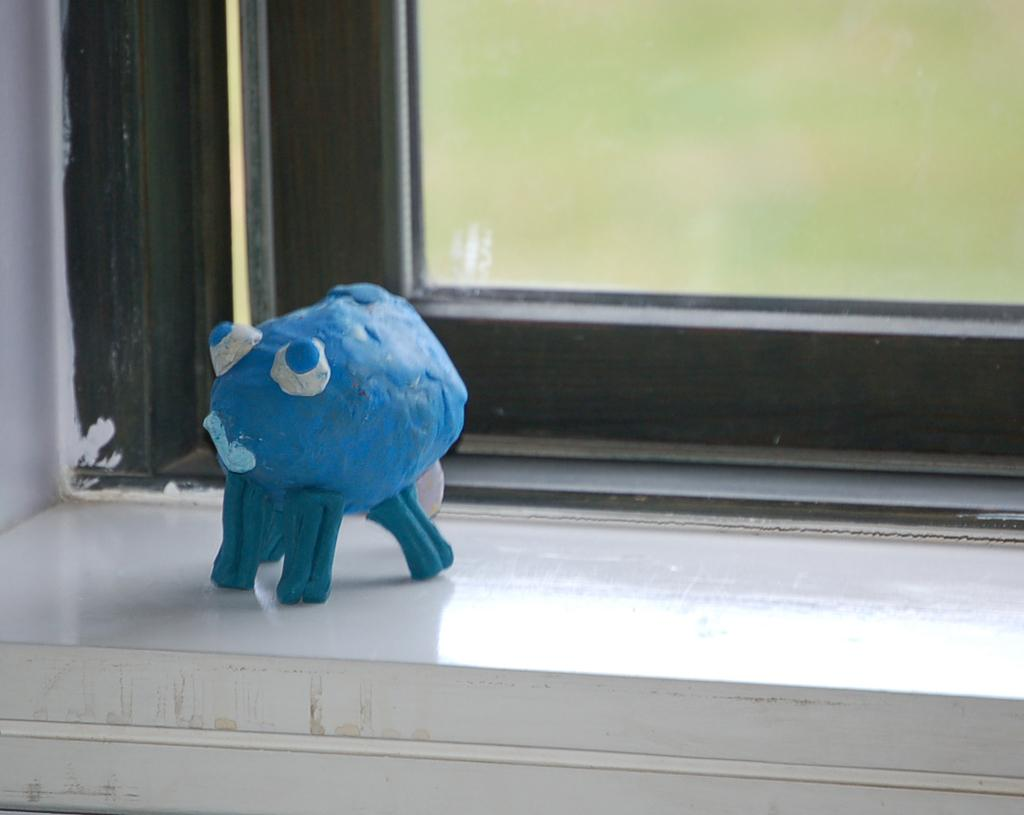What object can be seen in the image? There is a toy in the image. What color is the toy? The toy is blue in color. Where is the toy located? The toy is kept on a wall. What is the toy's appearance? The toy resembles an octopus. Is there a window visible in the image? Yes, there is a window visible in the background of the image. What type of quarter is depicted in the image? There is no quarter present in the image; it features a blue toy resembling an octopus. Can you describe the cat's behavior in the image? There is no cat present in the image. 